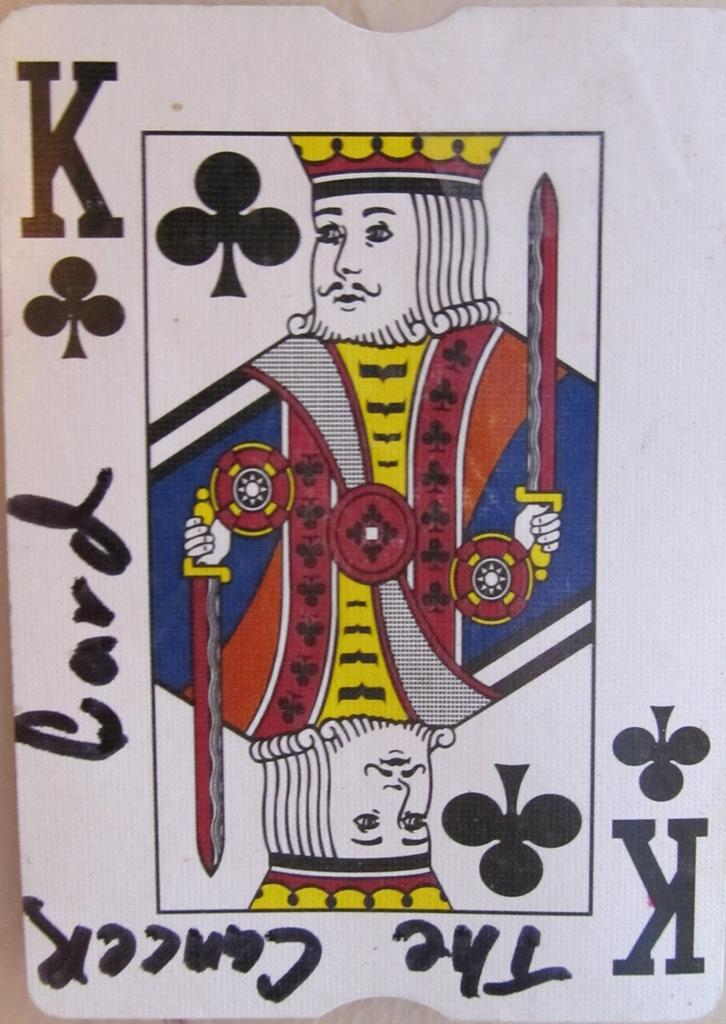Provide a one-sentence caption for the provided image. King card from a deck of playing cards with the cancer card wrote on it in black marker. 